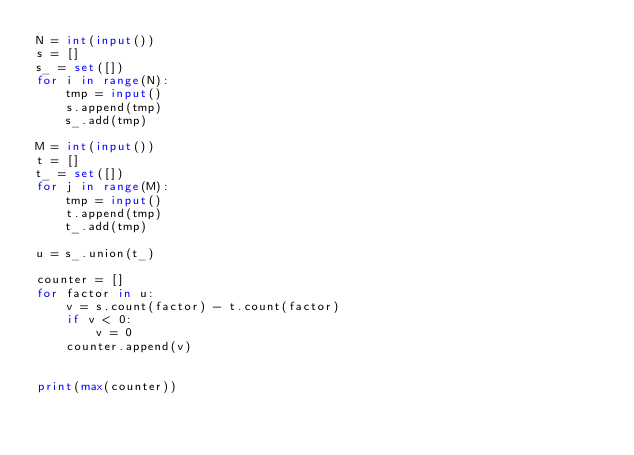<code> <loc_0><loc_0><loc_500><loc_500><_Python_>N = int(input())
s = []
s_ = set([])
for i in range(N):
    tmp = input()
    s.append(tmp)
    s_.add(tmp)

M = int(input())
t = []
t_ = set([])
for j in range(M):
    tmp = input()
    t.append(tmp)
    t_.add(tmp)

u = s_.union(t_)

counter = []
for factor in u:
    v = s.count(factor) - t.count(factor)
    if v < 0:
        v = 0
    counter.append(v)
    

print(max(counter))</code> 